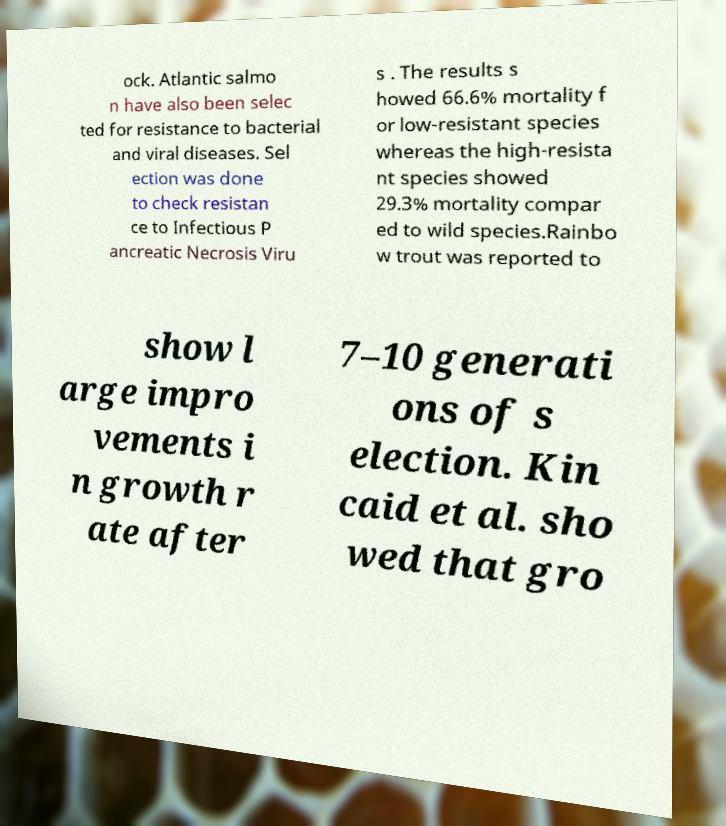For documentation purposes, I need the text within this image transcribed. Could you provide that? ock. Atlantic salmo n have also been selec ted for resistance to bacterial and viral diseases. Sel ection was done to check resistan ce to Infectious P ancreatic Necrosis Viru s . The results s howed 66.6% mortality f or low-resistant species whereas the high-resista nt species showed 29.3% mortality compar ed to wild species.Rainbo w trout was reported to show l arge impro vements i n growth r ate after 7–10 generati ons of s election. Kin caid et al. sho wed that gro 